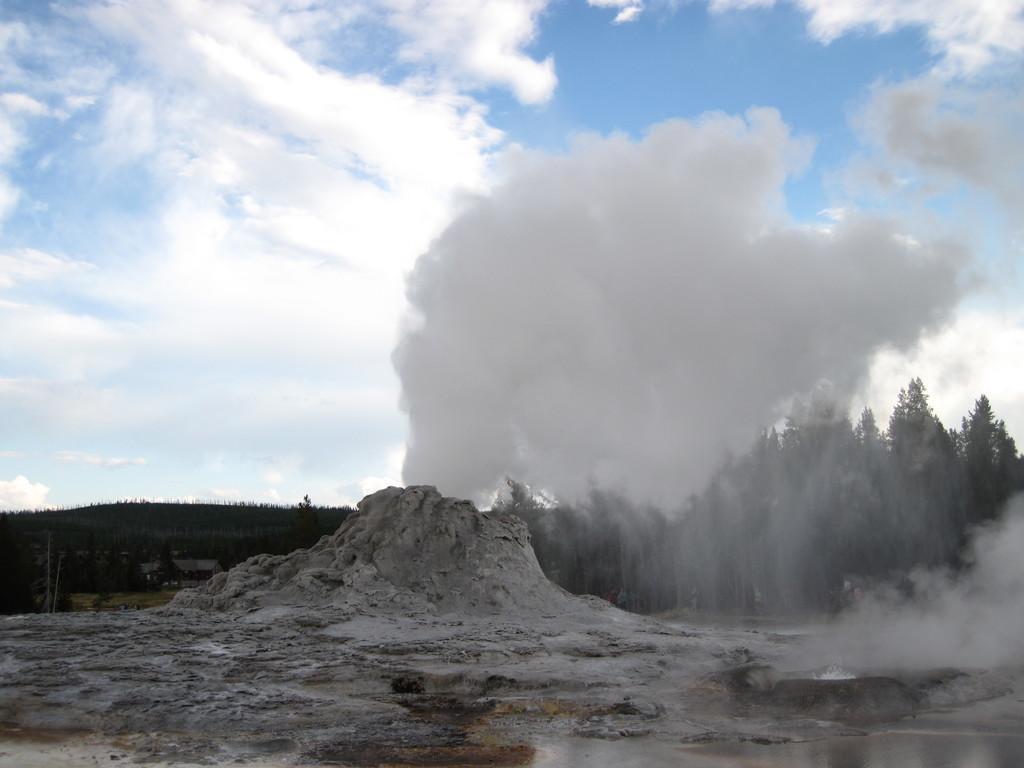Can you describe this image briefly? This picture is clicked outside. In the foreground we can see the water and see the mud. In the center we can see the trees and some other objects. In the background there is a sky and we can see the smoke. 